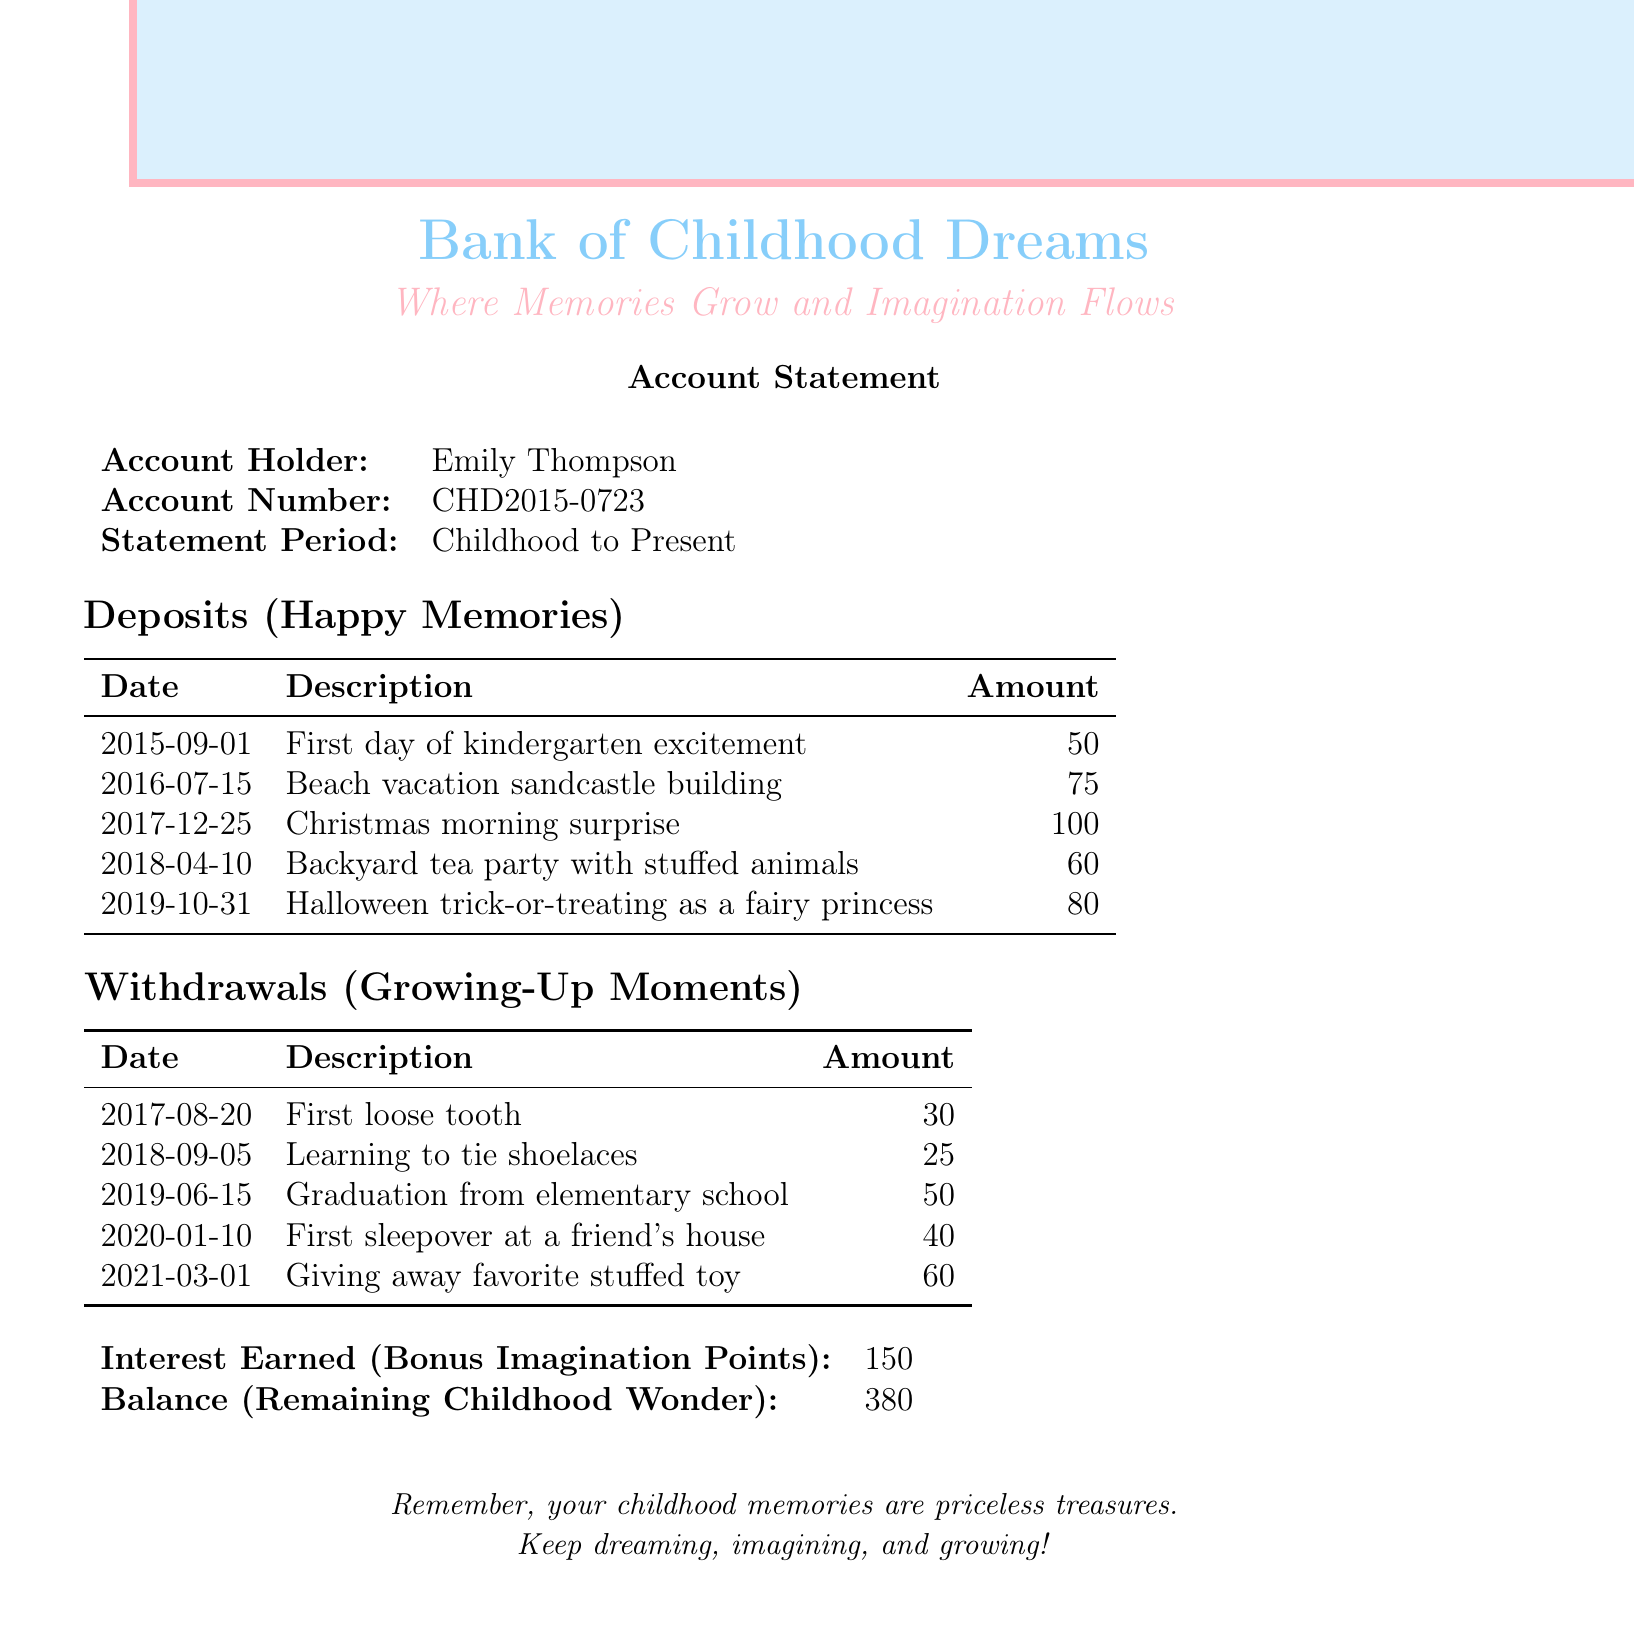What is the account holder's name? The account holder's name is stated at the beginning of the document.
Answer: Emily Thompson What is the amount of the deposit for the beach vacation? The document lists a specific deposit related to the beach vacation and its amount.
Answer: 75 When was the first loose tooth? The date of the first loose tooth withdrawal is noted in the withdrawals section.
Answer: 2017-08-20 What is the total amount of deposits? The total amount of deposits can be calculated by adding all the deposits listed in the document.
Answer: 365 How many withdrawals are listed in the document? The document enumerates the withdrawals, and counting them will provide the answer.
Answer: 5 What is the amount of interest earned? The document specifies the amount of interest earned as a single figure.
Answer: 150 What was the first happy memory deposit? The first deposit is chronologically ordered and is clearly stated in the deposits section.
Answer: First day of kindergarten excitement What does the balance represent? The document describes the balance in terms of the themes of childhood and wonder.
Answer: Remaining childhood wonder What type of moments are described as withdrawals? The document categorizes these experiences under a specific type.
Answer: Growing-Up Moments What is the significance of the statement period? The statement period outlines the timeframe that the document covers for the account activities.
Answer: Childhood to Present 